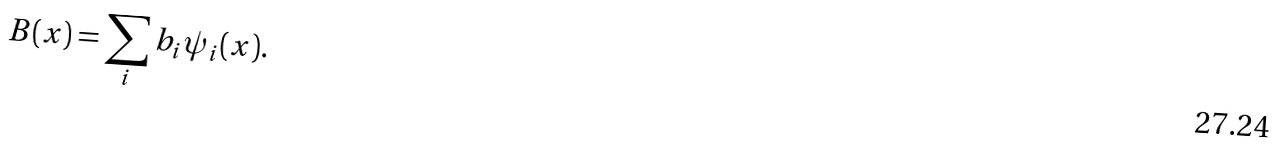<formula> <loc_0><loc_0><loc_500><loc_500>B ( { x } ) = \sum _ { i } b _ { i } \psi _ { i } ( { x } ) .</formula> 